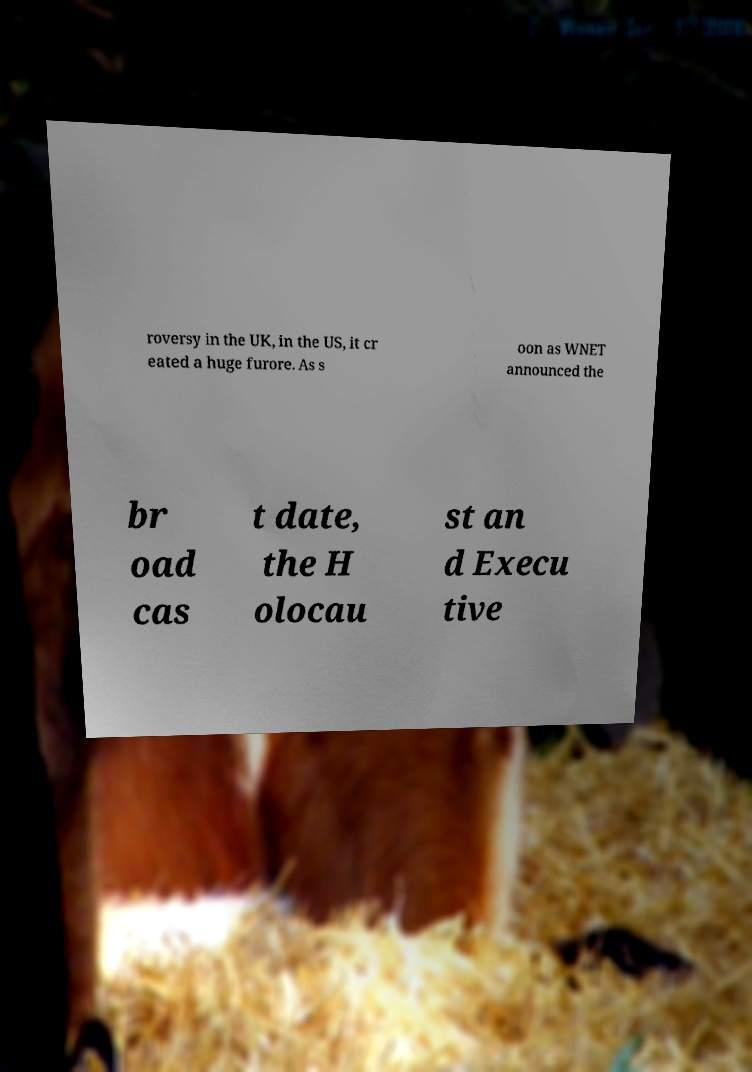Please read and relay the text visible in this image. What does it say? roversy in the UK, in the US, it cr eated a huge furore. As s oon as WNET announced the br oad cas t date, the H olocau st an d Execu tive 